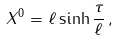Convert formula to latex. <formula><loc_0><loc_0><loc_500><loc_500>X ^ { 0 } = \ell \sinh \frac { \tau } { \ell } \, ,</formula> 